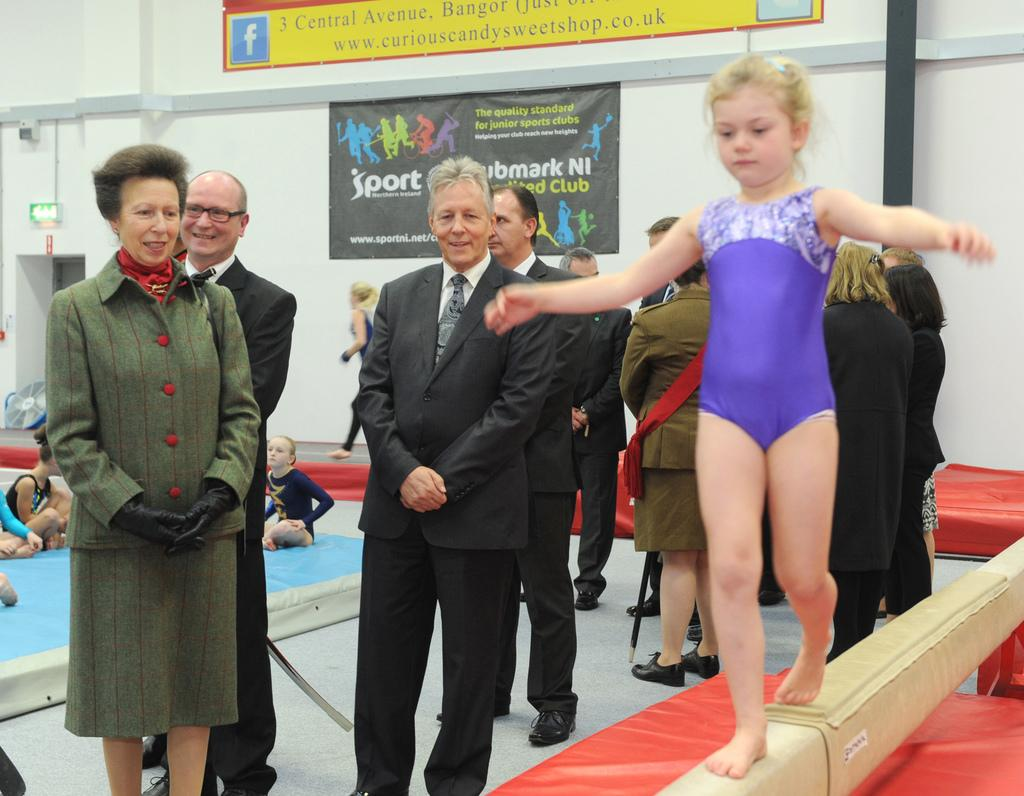What are the people doing in the image? The people are on colorful objects and standing on the floor in the image. What can be seen on the objects the people are on? There is text visible on the objects. What else is present in the image besides the people and objects? There are other objects present in the image. What type of boats can be seen in the image? There are no boats present in the image. What are the people reading in the image? There is no reading material visible in the image, and the people are not shown reading anything. 